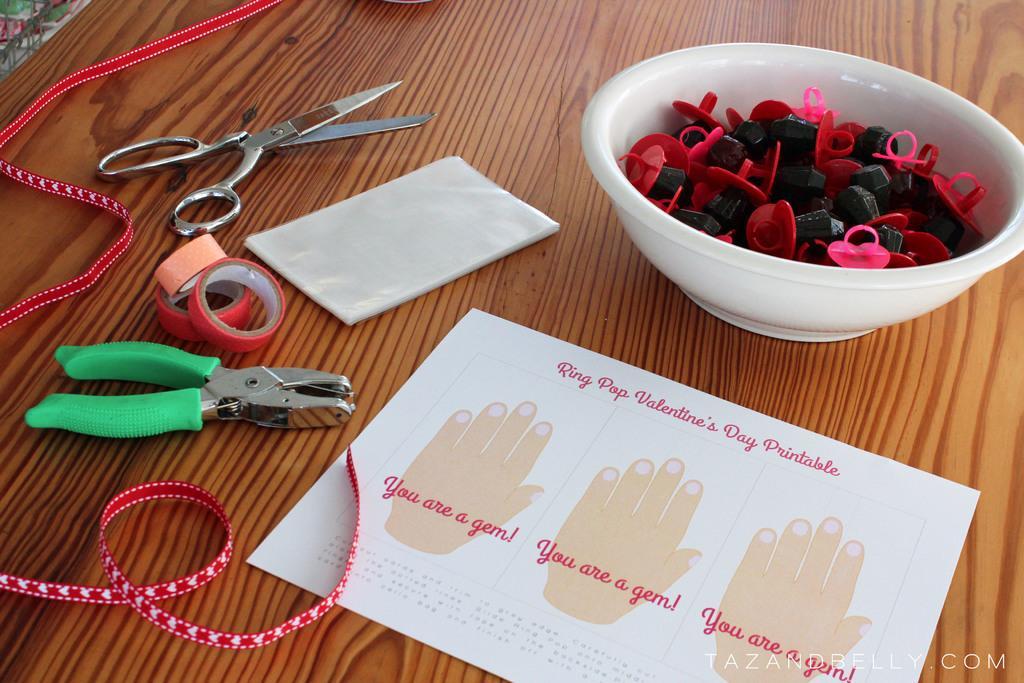Can you describe this image briefly? In this image there is a table in the center. On the table there are tapes, there is a scissor, cutting plier, ribbon and clips in the bowl which is white in colour and there is a paper on which some text is written on it. 